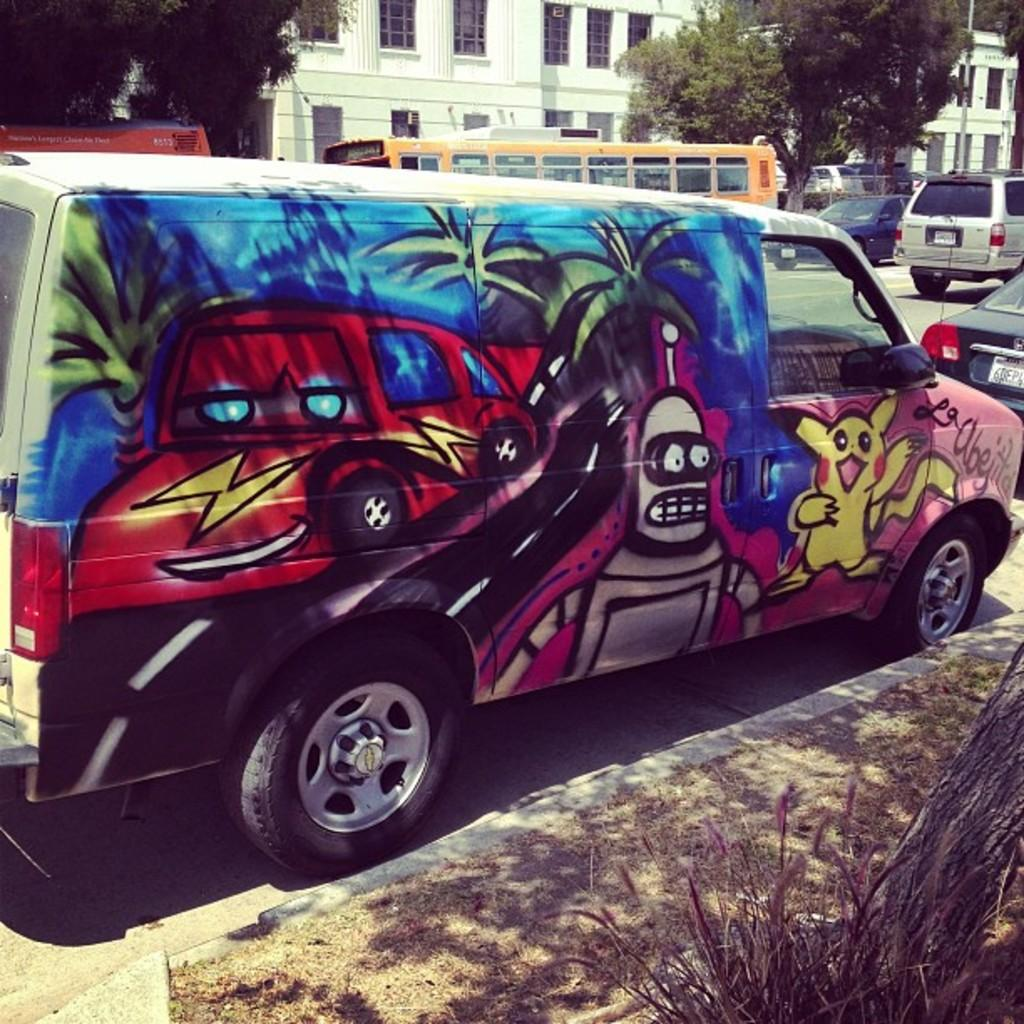What type of vehicle is in the image? There is a van in the image. What can be said about the appearance of the van? The van is colorful. Where is the van located in the image? The van is on the road. Are there any other vehicles in the image? Yes, there are other vehicles on the road. What can be seen in the background of the image? There are trees and white buildings in the background of the image. What type of bread is being served in the van's hat in the image? There is no bread or hat present in the image; it features a colorful van on the road with other vehicles and a background of trees and white buildings. 